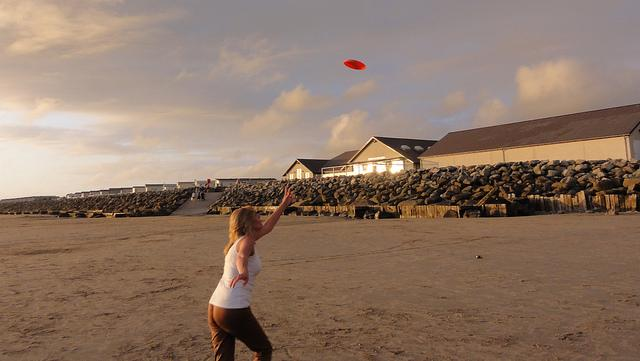What cut of shirt is she wearing?

Choices:
A) t-shirt
B) tank top
C) crop top
D) turtleneck tank top 